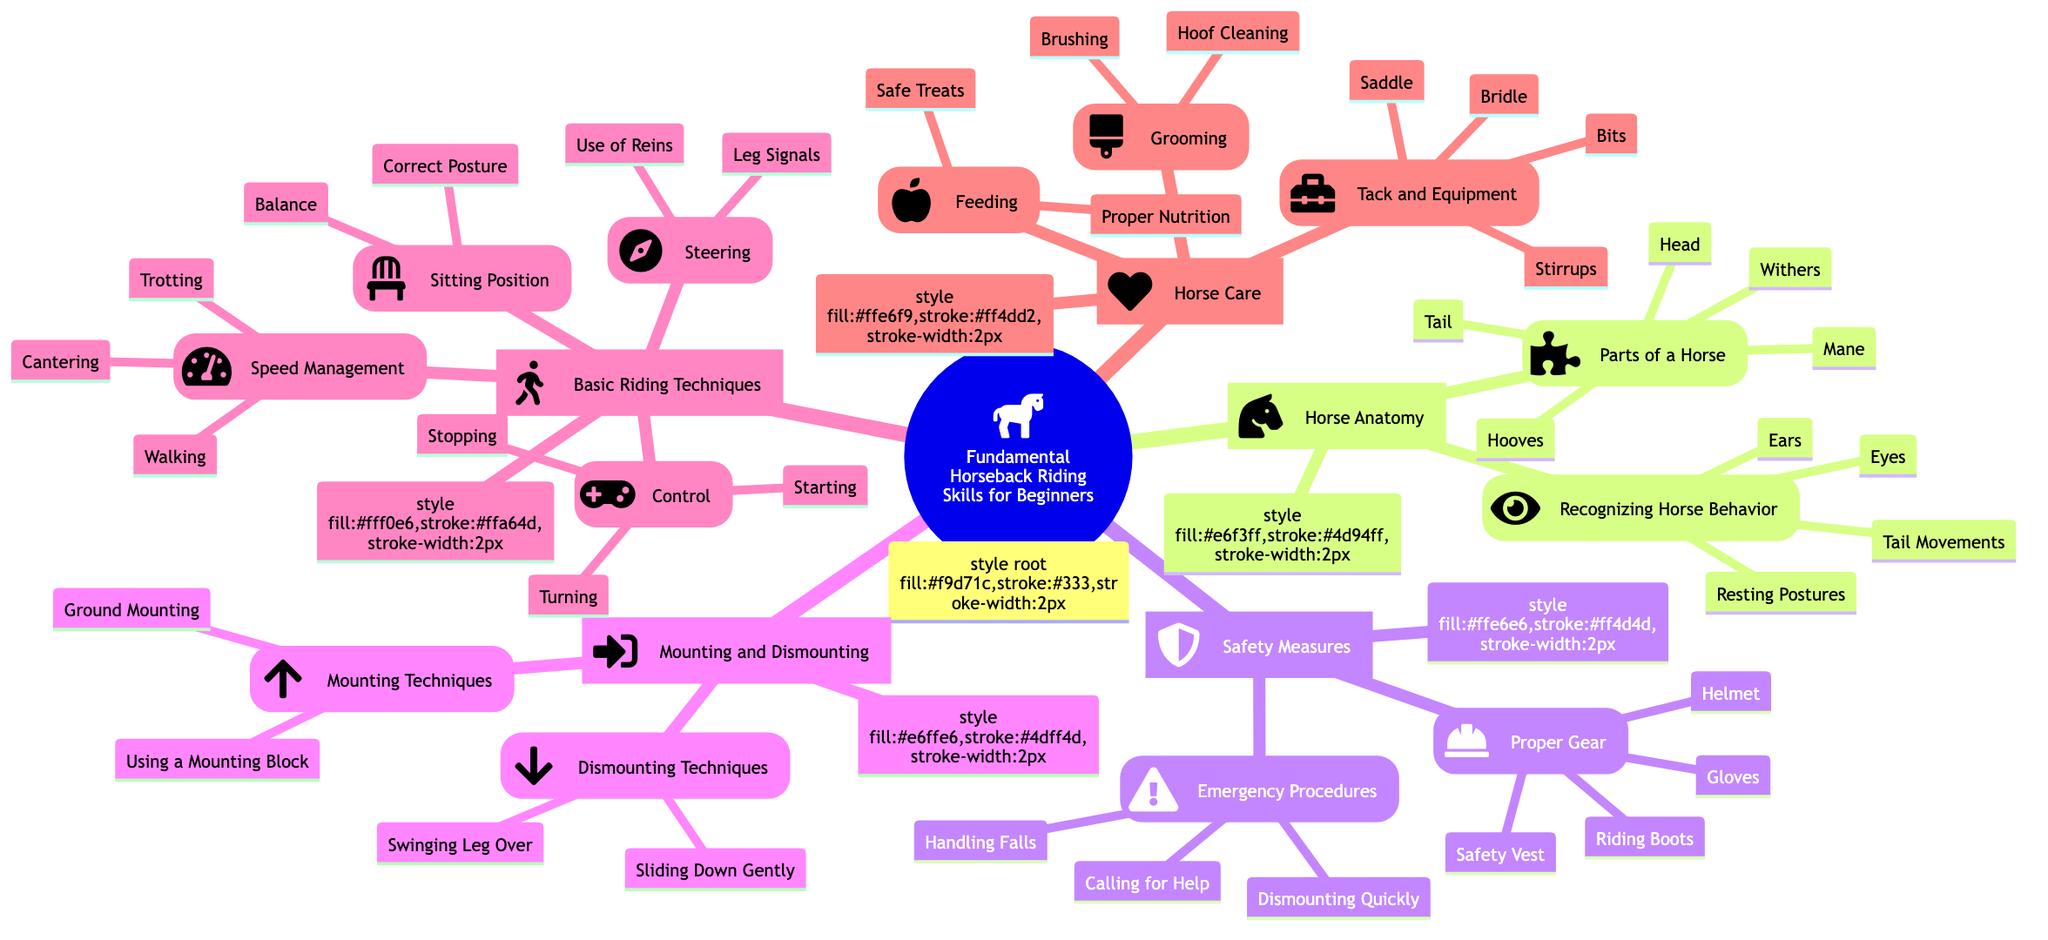What's the first main category present in the diagram? The first main category is identified as "Horse Anatomy" by looking at the top-level nodes under the root node which outlines the fundamental horseback riding skills.
Answer: Horse Anatomy How many parts of a horse are listed? The section "Parts of a Horse" contains five specific parts: Head, Mane, Withers, Hooves, and Tail. Counting these gives a total of five parts.
Answer: 5 What two techniques are included under "Mounting Techniques"? Under "Mounting Techniques," there are two methods listed: "Using a Mounting Block" and "Ground Mounting." These can be found under the relevant subsection.
Answer: Using a Mounting Block, Ground Mounting What are the types of safety gear mentioned? The list from the "Proper Gear" section includes four items: Helmet, Riding Boots, Gloves, and Safety Vest. These items are collectively grouped under safety measures.
Answer: Helmet, Riding Boots, Gloves, Safety Vest Which riding technique category mentions "Balance"? The "Sitting Position" category under "Basic Riding Techniques" mentions "Balance" as a crucial aspect of maintaining good posture while riding.
Answer: Sitting Position How does the "Steering" technique relate to "Control"? "Steering" techniques such as "Use of Reins" and "Leg Signals" are foundational skills that directly enhance the control over the horse, which includes starting, stopping, and turning. This shows the progression from steering to overall control in riding.
Answer: Steering enhances Control What actions can be taken under "Emergency Procedures"? The actions listed under "Emergency Procedures" include "Dismounting Quickly," "Handling Falls," and "Calling for Help." Each action is part of ensuring rider safety during emergencies.
Answer: Dismounting Quickly, Handling Falls, Calling for Help What is included in the "Grooming" category? The "Grooming" category includes two actions: "Brushing" and "Hoof Cleaning." These are essential for maintaining a horse's health and appearance, outlined clearly under horse care.
Answer: Brushing, Hoof Cleaning How many sub-categories are there in "Basic Riding Techniques"? The "Basic Riding Techniques" category includes four sub-categories: Sitting Position, Steering, Control, and Speed Management, making a total of four sub-categories.
Answer: 4 What two items are highlighted in horse care feeding practices? The "Feeding" section emphasizes "Proper Nutrition" and "Safe Treats" as key components for maintaining a horse's diet and health. These practices are mirrored in the diagram's care sections.
Answer: Proper Nutrition, Safe Treats 